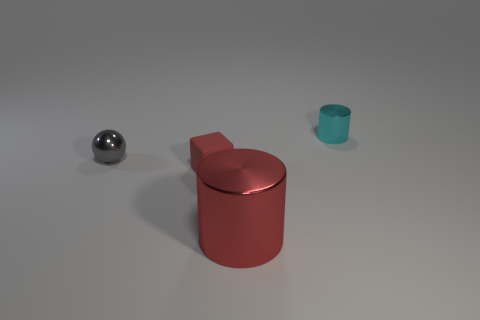Are there any other things that have the same size as the red cylinder?
Your answer should be compact. No. What number of tiny gray objects are there?
Offer a terse response. 1. Are there fewer tiny red things than small objects?
Your answer should be compact. Yes. What is the material of the red block that is the same size as the gray object?
Your answer should be very brief. Rubber. What number of things are large red shiny cylinders or tiny blue balls?
Your answer should be compact. 1. What number of metal things are both on the left side of the cyan shiny thing and behind the large red shiny cylinder?
Keep it short and to the point. 1. Are there fewer rubber cubes in front of the red matte thing than green objects?
Offer a very short reply. No. There is a gray metal thing that is the same size as the rubber cube; what is its shape?
Give a very brief answer. Sphere. What number of other objects are there of the same color as the cube?
Provide a short and direct response. 1. Is the size of the ball the same as the cube?
Keep it short and to the point. Yes. 